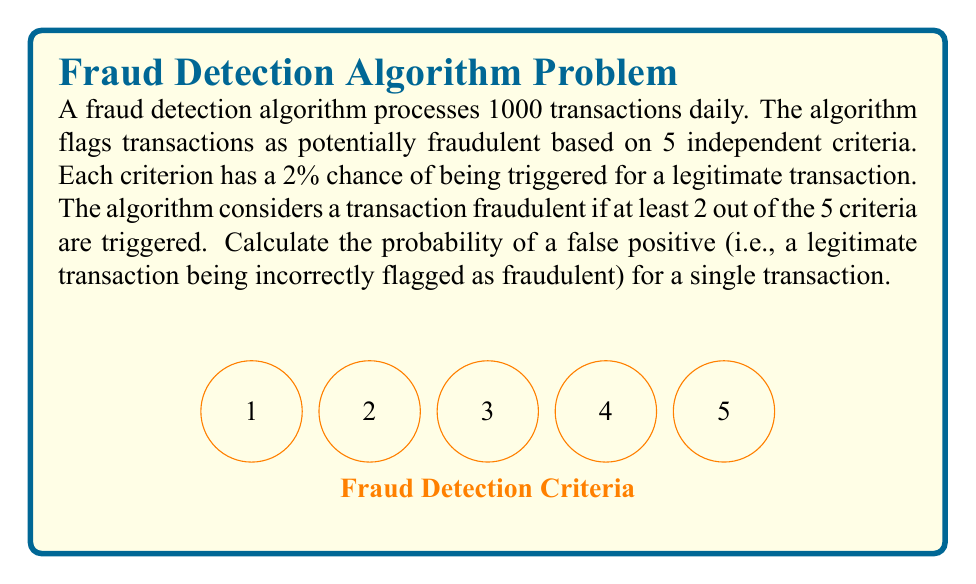Help me with this question. Let's approach this step-by-step:

1) First, we need to calculate the probability of a single criterion being triggered for a legitimate transaction. This is given as 2% or 0.02.

2) The probability of a criterion not being triggered is therefore 1 - 0.02 = 0.98.

3) We want the probability of at least 2 out of 5 criteria being triggered. It's easier to calculate this as 1 minus the probability of 0 or 1 criteria being triggered.

4) Let's use the binomial probability formula:

   $P(X = k) = \binom{n}{k} p^k (1-p)^{n-k}$

   where $n$ is the number of trials (5 in this case), $k$ is the number of successes, $p$ is the probability of success on a single trial (0.02 in this case).

5) Probability of 0 criteria being triggered:

   $P(X = 0) = \binom{5}{0} (0.02)^0 (0.98)^5 = 1 \cdot 1 \cdot 0.9039 = 0.9039$

6) Probability of 1 criterion being triggered:

   $P(X = 1) = \binom{5}{1} (0.02)^1 (0.98)^4 = 5 \cdot 0.02 \cdot 0.9224 = 0.0922$

7) Therefore, the probability of 0 or 1 criterion being triggered is:

   $P(X \leq 1) = 0.9039 + 0.0922 = 0.9961$

8) The probability of at least 2 criteria being triggered (our false positive rate) is:

   $P(X \geq 2) = 1 - P(X \leq 1) = 1 - 0.9961 = 0.0039$

Thus, the probability of a false positive for a single transaction is 0.0039 or 0.39%.
Answer: 0.0039 